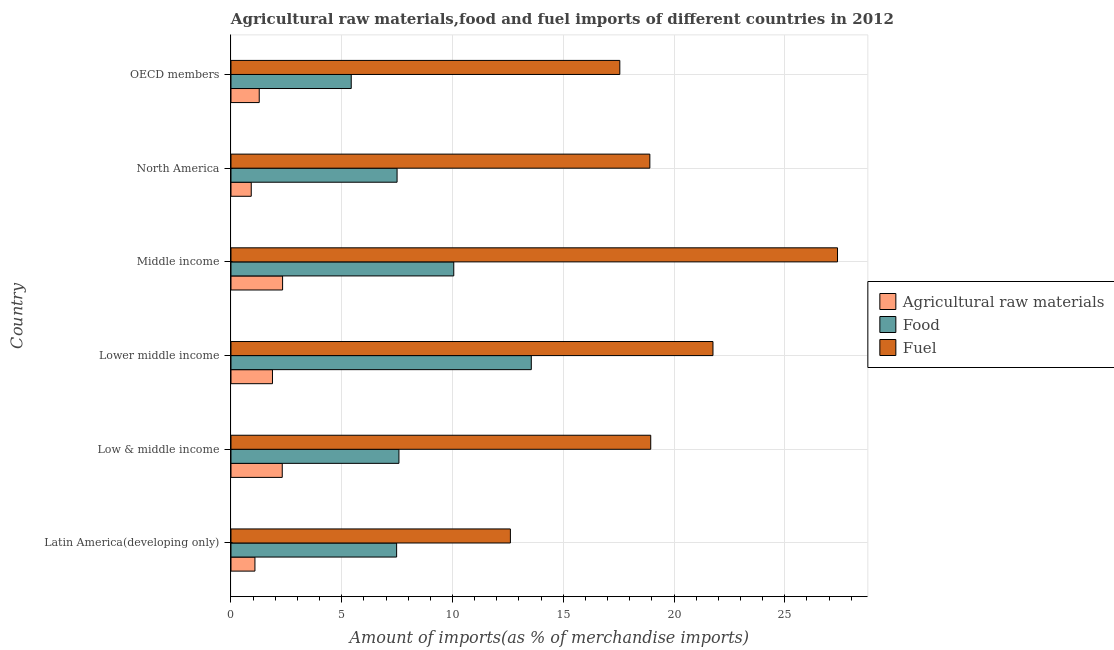How many groups of bars are there?
Provide a succinct answer. 6. Are the number of bars per tick equal to the number of legend labels?
Keep it short and to the point. Yes. What is the label of the 3rd group of bars from the top?
Offer a terse response. Middle income. What is the percentage of food imports in Middle income?
Offer a terse response. 10.06. Across all countries, what is the maximum percentage of food imports?
Ensure brevity in your answer.  13.56. Across all countries, what is the minimum percentage of fuel imports?
Provide a succinct answer. 12.61. In which country was the percentage of fuel imports minimum?
Provide a succinct answer. Latin America(developing only). What is the total percentage of food imports in the graph?
Offer a very short reply. 51.6. What is the difference between the percentage of fuel imports in Low & middle income and that in Lower middle income?
Your response must be concise. -2.81. What is the difference between the percentage of raw materials imports in Middle income and the percentage of food imports in OECD members?
Ensure brevity in your answer.  -3.1. What is the average percentage of fuel imports per country?
Give a very brief answer. 19.53. What is the difference between the percentage of fuel imports and percentage of food imports in North America?
Your answer should be compact. 11.41. What is the ratio of the percentage of fuel imports in Low & middle income to that in North America?
Make the answer very short. 1. Is the difference between the percentage of raw materials imports in North America and OECD members greater than the difference between the percentage of food imports in North America and OECD members?
Make the answer very short. No. What is the difference between the highest and the second highest percentage of fuel imports?
Ensure brevity in your answer.  5.62. What is the difference between the highest and the lowest percentage of fuel imports?
Offer a terse response. 14.77. Is the sum of the percentage of food imports in Lower middle income and OECD members greater than the maximum percentage of raw materials imports across all countries?
Offer a terse response. Yes. What does the 2nd bar from the top in Latin America(developing only) represents?
Your answer should be very brief. Food. What does the 3rd bar from the bottom in Low & middle income represents?
Your response must be concise. Fuel. Are all the bars in the graph horizontal?
Give a very brief answer. Yes. How many countries are there in the graph?
Your answer should be compact. 6. How are the legend labels stacked?
Provide a succinct answer. Vertical. What is the title of the graph?
Keep it short and to the point. Agricultural raw materials,food and fuel imports of different countries in 2012. What is the label or title of the X-axis?
Your answer should be compact. Amount of imports(as % of merchandise imports). What is the Amount of imports(as % of merchandise imports) in Agricultural raw materials in Latin America(developing only)?
Make the answer very short. 1.08. What is the Amount of imports(as % of merchandise imports) of Food in Latin America(developing only)?
Your answer should be very brief. 7.48. What is the Amount of imports(as % of merchandise imports) of Fuel in Latin America(developing only)?
Offer a very short reply. 12.61. What is the Amount of imports(as % of merchandise imports) of Agricultural raw materials in Low & middle income?
Provide a short and direct response. 2.31. What is the Amount of imports(as % of merchandise imports) of Food in Low & middle income?
Your response must be concise. 7.58. What is the Amount of imports(as % of merchandise imports) of Fuel in Low & middle income?
Your response must be concise. 18.95. What is the Amount of imports(as % of merchandise imports) of Agricultural raw materials in Lower middle income?
Your response must be concise. 1.87. What is the Amount of imports(as % of merchandise imports) of Food in Lower middle income?
Your answer should be compact. 13.56. What is the Amount of imports(as % of merchandise imports) in Fuel in Lower middle income?
Give a very brief answer. 21.76. What is the Amount of imports(as % of merchandise imports) of Agricultural raw materials in Middle income?
Provide a succinct answer. 2.33. What is the Amount of imports(as % of merchandise imports) of Food in Middle income?
Offer a very short reply. 10.06. What is the Amount of imports(as % of merchandise imports) of Fuel in Middle income?
Provide a short and direct response. 27.38. What is the Amount of imports(as % of merchandise imports) in Agricultural raw materials in North America?
Your response must be concise. 0.92. What is the Amount of imports(as % of merchandise imports) of Food in North America?
Your answer should be very brief. 7.5. What is the Amount of imports(as % of merchandise imports) in Fuel in North America?
Offer a very short reply. 18.91. What is the Amount of imports(as % of merchandise imports) of Agricultural raw materials in OECD members?
Make the answer very short. 1.28. What is the Amount of imports(as % of merchandise imports) of Food in OECD members?
Make the answer very short. 5.43. What is the Amount of imports(as % of merchandise imports) in Fuel in OECD members?
Ensure brevity in your answer.  17.55. Across all countries, what is the maximum Amount of imports(as % of merchandise imports) in Agricultural raw materials?
Provide a short and direct response. 2.33. Across all countries, what is the maximum Amount of imports(as % of merchandise imports) of Food?
Your answer should be compact. 13.56. Across all countries, what is the maximum Amount of imports(as % of merchandise imports) in Fuel?
Your answer should be compact. 27.38. Across all countries, what is the minimum Amount of imports(as % of merchandise imports) in Agricultural raw materials?
Your answer should be compact. 0.92. Across all countries, what is the minimum Amount of imports(as % of merchandise imports) in Food?
Your response must be concise. 5.43. Across all countries, what is the minimum Amount of imports(as % of merchandise imports) in Fuel?
Your response must be concise. 12.61. What is the total Amount of imports(as % of merchandise imports) in Agricultural raw materials in the graph?
Provide a short and direct response. 9.79. What is the total Amount of imports(as % of merchandise imports) of Food in the graph?
Give a very brief answer. 51.6. What is the total Amount of imports(as % of merchandise imports) in Fuel in the graph?
Give a very brief answer. 117.16. What is the difference between the Amount of imports(as % of merchandise imports) of Agricultural raw materials in Latin America(developing only) and that in Low & middle income?
Give a very brief answer. -1.23. What is the difference between the Amount of imports(as % of merchandise imports) in Food in Latin America(developing only) and that in Low & middle income?
Provide a succinct answer. -0.1. What is the difference between the Amount of imports(as % of merchandise imports) in Fuel in Latin America(developing only) and that in Low & middle income?
Your answer should be compact. -6.33. What is the difference between the Amount of imports(as % of merchandise imports) in Agricultural raw materials in Latin America(developing only) and that in Lower middle income?
Make the answer very short. -0.79. What is the difference between the Amount of imports(as % of merchandise imports) of Food in Latin America(developing only) and that in Lower middle income?
Your response must be concise. -6.08. What is the difference between the Amount of imports(as % of merchandise imports) in Fuel in Latin America(developing only) and that in Lower middle income?
Ensure brevity in your answer.  -9.14. What is the difference between the Amount of imports(as % of merchandise imports) in Agricultural raw materials in Latin America(developing only) and that in Middle income?
Keep it short and to the point. -1.25. What is the difference between the Amount of imports(as % of merchandise imports) in Food in Latin America(developing only) and that in Middle income?
Your response must be concise. -2.58. What is the difference between the Amount of imports(as % of merchandise imports) of Fuel in Latin America(developing only) and that in Middle income?
Your answer should be compact. -14.77. What is the difference between the Amount of imports(as % of merchandise imports) of Agricultural raw materials in Latin America(developing only) and that in North America?
Give a very brief answer. 0.17. What is the difference between the Amount of imports(as % of merchandise imports) in Food in Latin America(developing only) and that in North America?
Make the answer very short. -0.02. What is the difference between the Amount of imports(as % of merchandise imports) in Fuel in Latin America(developing only) and that in North America?
Your answer should be compact. -6.3. What is the difference between the Amount of imports(as % of merchandise imports) of Agricultural raw materials in Latin America(developing only) and that in OECD members?
Keep it short and to the point. -0.19. What is the difference between the Amount of imports(as % of merchandise imports) in Food in Latin America(developing only) and that in OECD members?
Your answer should be compact. 2.05. What is the difference between the Amount of imports(as % of merchandise imports) in Fuel in Latin America(developing only) and that in OECD members?
Your answer should be very brief. -4.94. What is the difference between the Amount of imports(as % of merchandise imports) in Agricultural raw materials in Low & middle income and that in Lower middle income?
Provide a short and direct response. 0.44. What is the difference between the Amount of imports(as % of merchandise imports) in Food in Low & middle income and that in Lower middle income?
Offer a very short reply. -5.97. What is the difference between the Amount of imports(as % of merchandise imports) of Fuel in Low & middle income and that in Lower middle income?
Your answer should be very brief. -2.81. What is the difference between the Amount of imports(as % of merchandise imports) in Agricultural raw materials in Low & middle income and that in Middle income?
Offer a very short reply. -0.02. What is the difference between the Amount of imports(as % of merchandise imports) in Food in Low & middle income and that in Middle income?
Your answer should be compact. -2.47. What is the difference between the Amount of imports(as % of merchandise imports) of Fuel in Low & middle income and that in Middle income?
Your answer should be compact. -8.43. What is the difference between the Amount of imports(as % of merchandise imports) in Agricultural raw materials in Low & middle income and that in North America?
Your answer should be very brief. 1.4. What is the difference between the Amount of imports(as % of merchandise imports) of Food in Low & middle income and that in North America?
Ensure brevity in your answer.  0.08. What is the difference between the Amount of imports(as % of merchandise imports) of Fuel in Low & middle income and that in North America?
Provide a succinct answer. 0.04. What is the difference between the Amount of imports(as % of merchandise imports) of Agricultural raw materials in Low & middle income and that in OECD members?
Give a very brief answer. 1.04. What is the difference between the Amount of imports(as % of merchandise imports) in Food in Low & middle income and that in OECD members?
Your answer should be very brief. 2.15. What is the difference between the Amount of imports(as % of merchandise imports) of Fuel in Low & middle income and that in OECD members?
Make the answer very short. 1.4. What is the difference between the Amount of imports(as % of merchandise imports) in Agricultural raw materials in Lower middle income and that in Middle income?
Your answer should be compact. -0.46. What is the difference between the Amount of imports(as % of merchandise imports) in Food in Lower middle income and that in Middle income?
Give a very brief answer. 3.5. What is the difference between the Amount of imports(as % of merchandise imports) of Fuel in Lower middle income and that in Middle income?
Provide a succinct answer. -5.62. What is the difference between the Amount of imports(as % of merchandise imports) of Agricultural raw materials in Lower middle income and that in North America?
Give a very brief answer. 0.96. What is the difference between the Amount of imports(as % of merchandise imports) of Food in Lower middle income and that in North America?
Offer a terse response. 6.06. What is the difference between the Amount of imports(as % of merchandise imports) in Fuel in Lower middle income and that in North America?
Provide a succinct answer. 2.85. What is the difference between the Amount of imports(as % of merchandise imports) of Agricultural raw materials in Lower middle income and that in OECD members?
Your answer should be compact. 0.6. What is the difference between the Amount of imports(as % of merchandise imports) of Food in Lower middle income and that in OECD members?
Keep it short and to the point. 8.13. What is the difference between the Amount of imports(as % of merchandise imports) in Fuel in Lower middle income and that in OECD members?
Keep it short and to the point. 4.21. What is the difference between the Amount of imports(as % of merchandise imports) of Agricultural raw materials in Middle income and that in North America?
Give a very brief answer. 1.42. What is the difference between the Amount of imports(as % of merchandise imports) of Food in Middle income and that in North America?
Your answer should be very brief. 2.56. What is the difference between the Amount of imports(as % of merchandise imports) of Fuel in Middle income and that in North America?
Your response must be concise. 8.47. What is the difference between the Amount of imports(as % of merchandise imports) of Agricultural raw materials in Middle income and that in OECD members?
Your response must be concise. 1.05. What is the difference between the Amount of imports(as % of merchandise imports) in Food in Middle income and that in OECD members?
Provide a short and direct response. 4.63. What is the difference between the Amount of imports(as % of merchandise imports) in Fuel in Middle income and that in OECD members?
Your response must be concise. 9.83. What is the difference between the Amount of imports(as % of merchandise imports) in Agricultural raw materials in North America and that in OECD members?
Offer a very short reply. -0.36. What is the difference between the Amount of imports(as % of merchandise imports) in Food in North America and that in OECD members?
Offer a very short reply. 2.07. What is the difference between the Amount of imports(as % of merchandise imports) in Fuel in North America and that in OECD members?
Your answer should be very brief. 1.36. What is the difference between the Amount of imports(as % of merchandise imports) of Agricultural raw materials in Latin America(developing only) and the Amount of imports(as % of merchandise imports) of Food in Low & middle income?
Your answer should be compact. -6.5. What is the difference between the Amount of imports(as % of merchandise imports) in Agricultural raw materials in Latin America(developing only) and the Amount of imports(as % of merchandise imports) in Fuel in Low & middle income?
Offer a very short reply. -17.87. What is the difference between the Amount of imports(as % of merchandise imports) of Food in Latin America(developing only) and the Amount of imports(as % of merchandise imports) of Fuel in Low & middle income?
Offer a terse response. -11.47. What is the difference between the Amount of imports(as % of merchandise imports) in Agricultural raw materials in Latin America(developing only) and the Amount of imports(as % of merchandise imports) in Food in Lower middle income?
Your answer should be very brief. -12.47. What is the difference between the Amount of imports(as % of merchandise imports) of Agricultural raw materials in Latin America(developing only) and the Amount of imports(as % of merchandise imports) of Fuel in Lower middle income?
Keep it short and to the point. -20.68. What is the difference between the Amount of imports(as % of merchandise imports) of Food in Latin America(developing only) and the Amount of imports(as % of merchandise imports) of Fuel in Lower middle income?
Keep it short and to the point. -14.28. What is the difference between the Amount of imports(as % of merchandise imports) in Agricultural raw materials in Latin America(developing only) and the Amount of imports(as % of merchandise imports) in Food in Middle income?
Provide a succinct answer. -8.98. What is the difference between the Amount of imports(as % of merchandise imports) in Agricultural raw materials in Latin America(developing only) and the Amount of imports(as % of merchandise imports) in Fuel in Middle income?
Keep it short and to the point. -26.3. What is the difference between the Amount of imports(as % of merchandise imports) in Food in Latin America(developing only) and the Amount of imports(as % of merchandise imports) in Fuel in Middle income?
Offer a very short reply. -19.9. What is the difference between the Amount of imports(as % of merchandise imports) of Agricultural raw materials in Latin America(developing only) and the Amount of imports(as % of merchandise imports) of Food in North America?
Offer a very short reply. -6.42. What is the difference between the Amount of imports(as % of merchandise imports) of Agricultural raw materials in Latin America(developing only) and the Amount of imports(as % of merchandise imports) of Fuel in North America?
Provide a succinct answer. -17.83. What is the difference between the Amount of imports(as % of merchandise imports) of Food in Latin America(developing only) and the Amount of imports(as % of merchandise imports) of Fuel in North America?
Provide a succinct answer. -11.43. What is the difference between the Amount of imports(as % of merchandise imports) in Agricultural raw materials in Latin America(developing only) and the Amount of imports(as % of merchandise imports) in Food in OECD members?
Provide a succinct answer. -4.35. What is the difference between the Amount of imports(as % of merchandise imports) in Agricultural raw materials in Latin America(developing only) and the Amount of imports(as % of merchandise imports) in Fuel in OECD members?
Your answer should be compact. -16.47. What is the difference between the Amount of imports(as % of merchandise imports) of Food in Latin America(developing only) and the Amount of imports(as % of merchandise imports) of Fuel in OECD members?
Your answer should be compact. -10.07. What is the difference between the Amount of imports(as % of merchandise imports) in Agricultural raw materials in Low & middle income and the Amount of imports(as % of merchandise imports) in Food in Lower middle income?
Give a very brief answer. -11.24. What is the difference between the Amount of imports(as % of merchandise imports) of Agricultural raw materials in Low & middle income and the Amount of imports(as % of merchandise imports) of Fuel in Lower middle income?
Provide a short and direct response. -19.44. What is the difference between the Amount of imports(as % of merchandise imports) of Food in Low & middle income and the Amount of imports(as % of merchandise imports) of Fuel in Lower middle income?
Provide a succinct answer. -14.18. What is the difference between the Amount of imports(as % of merchandise imports) of Agricultural raw materials in Low & middle income and the Amount of imports(as % of merchandise imports) of Food in Middle income?
Provide a short and direct response. -7.74. What is the difference between the Amount of imports(as % of merchandise imports) of Agricultural raw materials in Low & middle income and the Amount of imports(as % of merchandise imports) of Fuel in Middle income?
Provide a succinct answer. -25.06. What is the difference between the Amount of imports(as % of merchandise imports) of Food in Low & middle income and the Amount of imports(as % of merchandise imports) of Fuel in Middle income?
Your answer should be very brief. -19.8. What is the difference between the Amount of imports(as % of merchandise imports) in Agricultural raw materials in Low & middle income and the Amount of imports(as % of merchandise imports) in Food in North America?
Your answer should be very brief. -5.18. What is the difference between the Amount of imports(as % of merchandise imports) in Agricultural raw materials in Low & middle income and the Amount of imports(as % of merchandise imports) in Fuel in North America?
Give a very brief answer. -16.59. What is the difference between the Amount of imports(as % of merchandise imports) of Food in Low & middle income and the Amount of imports(as % of merchandise imports) of Fuel in North America?
Give a very brief answer. -11.33. What is the difference between the Amount of imports(as % of merchandise imports) of Agricultural raw materials in Low & middle income and the Amount of imports(as % of merchandise imports) of Food in OECD members?
Your answer should be compact. -3.11. What is the difference between the Amount of imports(as % of merchandise imports) in Agricultural raw materials in Low & middle income and the Amount of imports(as % of merchandise imports) in Fuel in OECD members?
Your answer should be compact. -15.24. What is the difference between the Amount of imports(as % of merchandise imports) of Food in Low & middle income and the Amount of imports(as % of merchandise imports) of Fuel in OECD members?
Ensure brevity in your answer.  -9.97. What is the difference between the Amount of imports(as % of merchandise imports) of Agricultural raw materials in Lower middle income and the Amount of imports(as % of merchandise imports) of Food in Middle income?
Provide a short and direct response. -8.18. What is the difference between the Amount of imports(as % of merchandise imports) of Agricultural raw materials in Lower middle income and the Amount of imports(as % of merchandise imports) of Fuel in Middle income?
Make the answer very short. -25.51. What is the difference between the Amount of imports(as % of merchandise imports) in Food in Lower middle income and the Amount of imports(as % of merchandise imports) in Fuel in Middle income?
Your response must be concise. -13.82. What is the difference between the Amount of imports(as % of merchandise imports) in Agricultural raw materials in Lower middle income and the Amount of imports(as % of merchandise imports) in Food in North America?
Provide a succinct answer. -5.63. What is the difference between the Amount of imports(as % of merchandise imports) in Agricultural raw materials in Lower middle income and the Amount of imports(as % of merchandise imports) in Fuel in North America?
Make the answer very short. -17.04. What is the difference between the Amount of imports(as % of merchandise imports) in Food in Lower middle income and the Amount of imports(as % of merchandise imports) in Fuel in North America?
Provide a succinct answer. -5.35. What is the difference between the Amount of imports(as % of merchandise imports) of Agricultural raw materials in Lower middle income and the Amount of imports(as % of merchandise imports) of Food in OECD members?
Make the answer very short. -3.56. What is the difference between the Amount of imports(as % of merchandise imports) of Agricultural raw materials in Lower middle income and the Amount of imports(as % of merchandise imports) of Fuel in OECD members?
Provide a succinct answer. -15.68. What is the difference between the Amount of imports(as % of merchandise imports) of Food in Lower middle income and the Amount of imports(as % of merchandise imports) of Fuel in OECD members?
Offer a terse response. -4. What is the difference between the Amount of imports(as % of merchandise imports) of Agricultural raw materials in Middle income and the Amount of imports(as % of merchandise imports) of Food in North America?
Make the answer very short. -5.17. What is the difference between the Amount of imports(as % of merchandise imports) of Agricultural raw materials in Middle income and the Amount of imports(as % of merchandise imports) of Fuel in North America?
Provide a short and direct response. -16.58. What is the difference between the Amount of imports(as % of merchandise imports) in Food in Middle income and the Amount of imports(as % of merchandise imports) in Fuel in North America?
Offer a very short reply. -8.85. What is the difference between the Amount of imports(as % of merchandise imports) of Agricultural raw materials in Middle income and the Amount of imports(as % of merchandise imports) of Food in OECD members?
Ensure brevity in your answer.  -3.1. What is the difference between the Amount of imports(as % of merchandise imports) of Agricultural raw materials in Middle income and the Amount of imports(as % of merchandise imports) of Fuel in OECD members?
Provide a succinct answer. -15.22. What is the difference between the Amount of imports(as % of merchandise imports) of Food in Middle income and the Amount of imports(as % of merchandise imports) of Fuel in OECD members?
Provide a short and direct response. -7.5. What is the difference between the Amount of imports(as % of merchandise imports) in Agricultural raw materials in North America and the Amount of imports(as % of merchandise imports) in Food in OECD members?
Your answer should be very brief. -4.51. What is the difference between the Amount of imports(as % of merchandise imports) in Agricultural raw materials in North America and the Amount of imports(as % of merchandise imports) in Fuel in OECD members?
Your answer should be compact. -16.64. What is the difference between the Amount of imports(as % of merchandise imports) of Food in North America and the Amount of imports(as % of merchandise imports) of Fuel in OECD members?
Your response must be concise. -10.05. What is the average Amount of imports(as % of merchandise imports) in Agricultural raw materials per country?
Provide a short and direct response. 1.63. What is the average Amount of imports(as % of merchandise imports) of Food per country?
Give a very brief answer. 8.6. What is the average Amount of imports(as % of merchandise imports) of Fuel per country?
Give a very brief answer. 19.53. What is the difference between the Amount of imports(as % of merchandise imports) in Agricultural raw materials and Amount of imports(as % of merchandise imports) in Food in Latin America(developing only)?
Keep it short and to the point. -6.4. What is the difference between the Amount of imports(as % of merchandise imports) of Agricultural raw materials and Amount of imports(as % of merchandise imports) of Fuel in Latin America(developing only)?
Offer a terse response. -11.53. What is the difference between the Amount of imports(as % of merchandise imports) of Food and Amount of imports(as % of merchandise imports) of Fuel in Latin America(developing only)?
Your answer should be very brief. -5.14. What is the difference between the Amount of imports(as % of merchandise imports) in Agricultural raw materials and Amount of imports(as % of merchandise imports) in Food in Low & middle income?
Your answer should be compact. -5.27. What is the difference between the Amount of imports(as % of merchandise imports) of Agricultural raw materials and Amount of imports(as % of merchandise imports) of Fuel in Low & middle income?
Ensure brevity in your answer.  -16.63. What is the difference between the Amount of imports(as % of merchandise imports) of Food and Amount of imports(as % of merchandise imports) of Fuel in Low & middle income?
Keep it short and to the point. -11.37. What is the difference between the Amount of imports(as % of merchandise imports) of Agricultural raw materials and Amount of imports(as % of merchandise imports) of Food in Lower middle income?
Your response must be concise. -11.68. What is the difference between the Amount of imports(as % of merchandise imports) in Agricultural raw materials and Amount of imports(as % of merchandise imports) in Fuel in Lower middle income?
Ensure brevity in your answer.  -19.89. What is the difference between the Amount of imports(as % of merchandise imports) of Food and Amount of imports(as % of merchandise imports) of Fuel in Lower middle income?
Keep it short and to the point. -8.2. What is the difference between the Amount of imports(as % of merchandise imports) of Agricultural raw materials and Amount of imports(as % of merchandise imports) of Food in Middle income?
Offer a terse response. -7.73. What is the difference between the Amount of imports(as % of merchandise imports) in Agricultural raw materials and Amount of imports(as % of merchandise imports) in Fuel in Middle income?
Your response must be concise. -25.05. What is the difference between the Amount of imports(as % of merchandise imports) of Food and Amount of imports(as % of merchandise imports) of Fuel in Middle income?
Your answer should be compact. -17.32. What is the difference between the Amount of imports(as % of merchandise imports) in Agricultural raw materials and Amount of imports(as % of merchandise imports) in Food in North America?
Your answer should be very brief. -6.58. What is the difference between the Amount of imports(as % of merchandise imports) of Agricultural raw materials and Amount of imports(as % of merchandise imports) of Fuel in North America?
Offer a terse response. -17.99. What is the difference between the Amount of imports(as % of merchandise imports) in Food and Amount of imports(as % of merchandise imports) in Fuel in North America?
Your answer should be compact. -11.41. What is the difference between the Amount of imports(as % of merchandise imports) in Agricultural raw materials and Amount of imports(as % of merchandise imports) in Food in OECD members?
Offer a very short reply. -4.15. What is the difference between the Amount of imports(as % of merchandise imports) in Agricultural raw materials and Amount of imports(as % of merchandise imports) in Fuel in OECD members?
Offer a very short reply. -16.28. What is the difference between the Amount of imports(as % of merchandise imports) of Food and Amount of imports(as % of merchandise imports) of Fuel in OECD members?
Ensure brevity in your answer.  -12.12. What is the ratio of the Amount of imports(as % of merchandise imports) of Agricultural raw materials in Latin America(developing only) to that in Low & middle income?
Your answer should be compact. 0.47. What is the ratio of the Amount of imports(as % of merchandise imports) of Food in Latin America(developing only) to that in Low & middle income?
Ensure brevity in your answer.  0.99. What is the ratio of the Amount of imports(as % of merchandise imports) in Fuel in Latin America(developing only) to that in Low & middle income?
Offer a terse response. 0.67. What is the ratio of the Amount of imports(as % of merchandise imports) in Agricultural raw materials in Latin America(developing only) to that in Lower middle income?
Make the answer very short. 0.58. What is the ratio of the Amount of imports(as % of merchandise imports) of Food in Latin America(developing only) to that in Lower middle income?
Provide a succinct answer. 0.55. What is the ratio of the Amount of imports(as % of merchandise imports) of Fuel in Latin America(developing only) to that in Lower middle income?
Make the answer very short. 0.58. What is the ratio of the Amount of imports(as % of merchandise imports) in Agricultural raw materials in Latin America(developing only) to that in Middle income?
Offer a terse response. 0.46. What is the ratio of the Amount of imports(as % of merchandise imports) of Food in Latin America(developing only) to that in Middle income?
Give a very brief answer. 0.74. What is the ratio of the Amount of imports(as % of merchandise imports) of Fuel in Latin America(developing only) to that in Middle income?
Ensure brevity in your answer.  0.46. What is the ratio of the Amount of imports(as % of merchandise imports) of Agricultural raw materials in Latin America(developing only) to that in North America?
Provide a short and direct response. 1.18. What is the ratio of the Amount of imports(as % of merchandise imports) of Fuel in Latin America(developing only) to that in North America?
Offer a very short reply. 0.67. What is the ratio of the Amount of imports(as % of merchandise imports) in Agricultural raw materials in Latin America(developing only) to that in OECD members?
Make the answer very short. 0.85. What is the ratio of the Amount of imports(as % of merchandise imports) of Food in Latin America(developing only) to that in OECD members?
Your answer should be compact. 1.38. What is the ratio of the Amount of imports(as % of merchandise imports) in Fuel in Latin America(developing only) to that in OECD members?
Provide a short and direct response. 0.72. What is the ratio of the Amount of imports(as % of merchandise imports) in Agricultural raw materials in Low & middle income to that in Lower middle income?
Offer a terse response. 1.24. What is the ratio of the Amount of imports(as % of merchandise imports) of Food in Low & middle income to that in Lower middle income?
Your response must be concise. 0.56. What is the ratio of the Amount of imports(as % of merchandise imports) of Fuel in Low & middle income to that in Lower middle income?
Make the answer very short. 0.87. What is the ratio of the Amount of imports(as % of merchandise imports) in Food in Low & middle income to that in Middle income?
Provide a succinct answer. 0.75. What is the ratio of the Amount of imports(as % of merchandise imports) of Fuel in Low & middle income to that in Middle income?
Offer a terse response. 0.69. What is the ratio of the Amount of imports(as % of merchandise imports) in Agricultural raw materials in Low & middle income to that in North America?
Offer a very short reply. 2.53. What is the ratio of the Amount of imports(as % of merchandise imports) in Food in Low & middle income to that in North America?
Provide a succinct answer. 1.01. What is the ratio of the Amount of imports(as % of merchandise imports) in Fuel in Low & middle income to that in North America?
Provide a succinct answer. 1. What is the ratio of the Amount of imports(as % of merchandise imports) of Agricultural raw materials in Low & middle income to that in OECD members?
Offer a very short reply. 1.81. What is the ratio of the Amount of imports(as % of merchandise imports) in Food in Low & middle income to that in OECD members?
Ensure brevity in your answer.  1.4. What is the ratio of the Amount of imports(as % of merchandise imports) in Fuel in Low & middle income to that in OECD members?
Your answer should be compact. 1.08. What is the ratio of the Amount of imports(as % of merchandise imports) in Agricultural raw materials in Lower middle income to that in Middle income?
Provide a short and direct response. 0.8. What is the ratio of the Amount of imports(as % of merchandise imports) in Food in Lower middle income to that in Middle income?
Provide a short and direct response. 1.35. What is the ratio of the Amount of imports(as % of merchandise imports) of Fuel in Lower middle income to that in Middle income?
Your response must be concise. 0.79. What is the ratio of the Amount of imports(as % of merchandise imports) of Agricultural raw materials in Lower middle income to that in North America?
Provide a short and direct response. 2.05. What is the ratio of the Amount of imports(as % of merchandise imports) in Food in Lower middle income to that in North America?
Your answer should be compact. 1.81. What is the ratio of the Amount of imports(as % of merchandise imports) in Fuel in Lower middle income to that in North America?
Make the answer very short. 1.15. What is the ratio of the Amount of imports(as % of merchandise imports) in Agricultural raw materials in Lower middle income to that in OECD members?
Offer a terse response. 1.47. What is the ratio of the Amount of imports(as % of merchandise imports) of Food in Lower middle income to that in OECD members?
Your answer should be compact. 2.5. What is the ratio of the Amount of imports(as % of merchandise imports) of Fuel in Lower middle income to that in OECD members?
Keep it short and to the point. 1.24. What is the ratio of the Amount of imports(as % of merchandise imports) in Agricultural raw materials in Middle income to that in North America?
Offer a very short reply. 2.55. What is the ratio of the Amount of imports(as % of merchandise imports) in Food in Middle income to that in North America?
Give a very brief answer. 1.34. What is the ratio of the Amount of imports(as % of merchandise imports) of Fuel in Middle income to that in North America?
Provide a succinct answer. 1.45. What is the ratio of the Amount of imports(as % of merchandise imports) of Agricultural raw materials in Middle income to that in OECD members?
Make the answer very short. 1.83. What is the ratio of the Amount of imports(as % of merchandise imports) in Food in Middle income to that in OECD members?
Offer a terse response. 1.85. What is the ratio of the Amount of imports(as % of merchandise imports) in Fuel in Middle income to that in OECD members?
Your answer should be compact. 1.56. What is the ratio of the Amount of imports(as % of merchandise imports) of Agricultural raw materials in North America to that in OECD members?
Keep it short and to the point. 0.72. What is the ratio of the Amount of imports(as % of merchandise imports) in Food in North America to that in OECD members?
Provide a succinct answer. 1.38. What is the ratio of the Amount of imports(as % of merchandise imports) in Fuel in North America to that in OECD members?
Give a very brief answer. 1.08. What is the difference between the highest and the second highest Amount of imports(as % of merchandise imports) in Agricultural raw materials?
Make the answer very short. 0.02. What is the difference between the highest and the second highest Amount of imports(as % of merchandise imports) in Food?
Keep it short and to the point. 3.5. What is the difference between the highest and the second highest Amount of imports(as % of merchandise imports) in Fuel?
Ensure brevity in your answer.  5.62. What is the difference between the highest and the lowest Amount of imports(as % of merchandise imports) of Agricultural raw materials?
Offer a terse response. 1.42. What is the difference between the highest and the lowest Amount of imports(as % of merchandise imports) of Food?
Your response must be concise. 8.13. What is the difference between the highest and the lowest Amount of imports(as % of merchandise imports) in Fuel?
Offer a terse response. 14.77. 